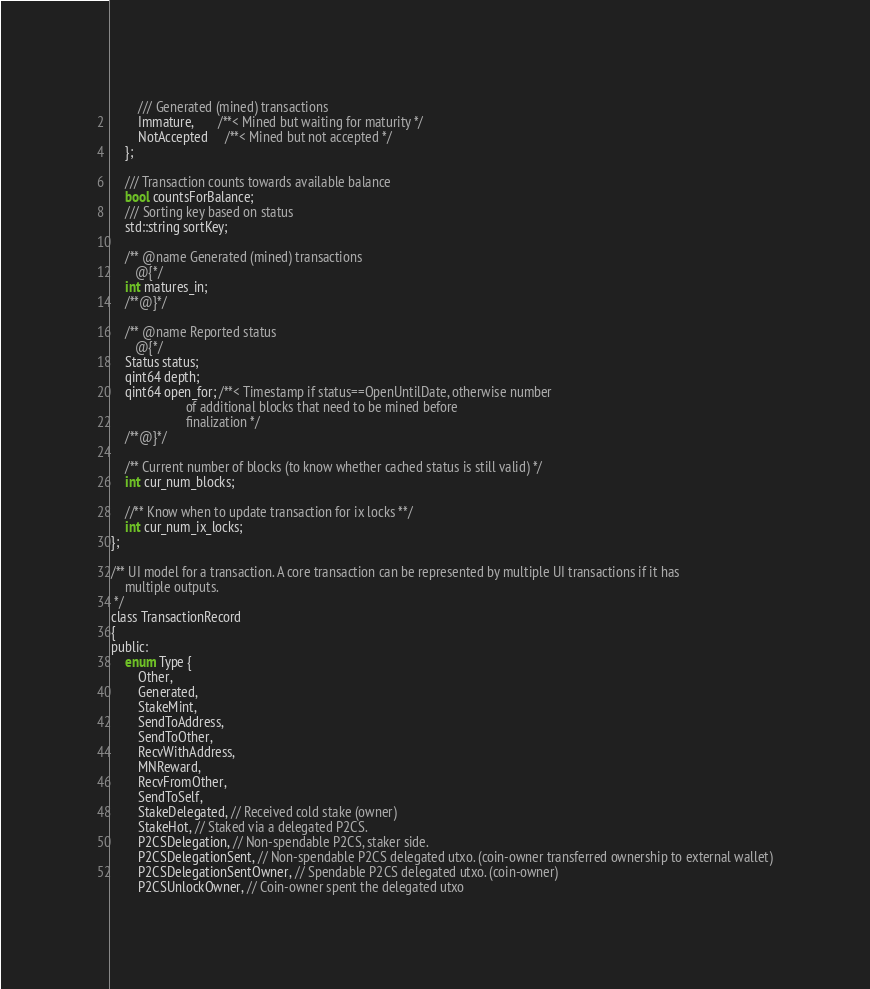Convert code to text. <code><loc_0><loc_0><loc_500><loc_500><_C_>        /// Generated (mined) transactions
        Immature,       /**< Mined but waiting for maturity */
        NotAccepted     /**< Mined but not accepted */
    };

    /// Transaction counts towards available balance
    bool countsForBalance;
    /// Sorting key based on status
    std::string sortKey;

    /** @name Generated (mined) transactions
       @{*/
    int matures_in;
    /**@}*/

    /** @name Reported status
       @{*/
    Status status;
    qint64 depth;
    qint64 open_for; /**< Timestamp if status==OpenUntilDate, otherwise number
                      of additional blocks that need to be mined before
                      finalization */
    /**@}*/

    /** Current number of blocks (to know whether cached status is still valid) */
    int cur_num_blocks;

    //** Know when to update transaction for ix locks **/
    int cur_num_ix_locks;
};

/** UI model for a transaction. A core transaction can be represented by multiple UI transactions if it has
    multiple outputs.
 */
class TransactionRecord
{
public:
    enum Type {
        Other,
        Generated,
        StakeMint,
        SendToAddress,
        SendToOther,
        RecvWithAddress,
        MNReward,
        RecvFromOther,
        SendToSelf,
        StakeDelegated, // Received cold stake (owner)
        StakeHot, // Staked via a delegated P2CS.
        P2CSDelegation, // Non-spendable P2CS, staker side.
        P2CSDelegationSent, // Non-spendable P2CS delegated utxo. (coin-owner transferred ownership to external wallet)
        P2CSDelegationSentOwner, // Spendable P2CS delegated utxo. (coin-owner)
        P2CSUnlockOwner, // Coin-owner spent the delegated utxo</code> 